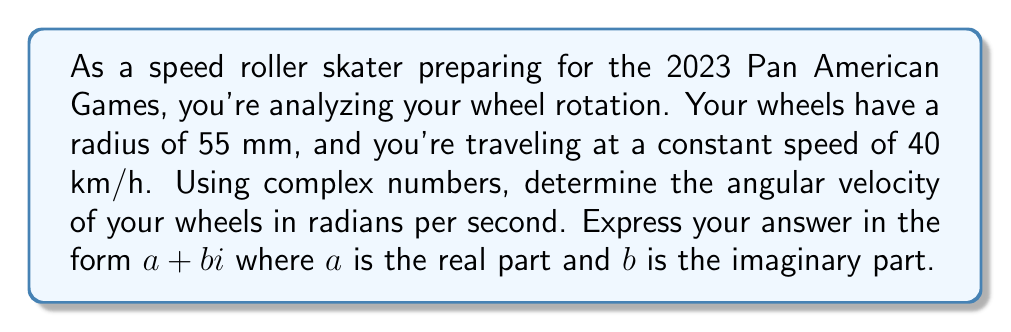Show me your answer to this math problem. Let's approach this step-by-step:

1) First, we need to convert the speed from km/h to m/s:
   $40 \text{ km/h} = 40 \times \frac{1000}{3600} \text{ m/s} = \frac{100}{9} \text{ m/s}$

2) The linear velocity $v$ is related to angular velocity $\omega$ by the equation:
   $v = r\omega$, where $r$ is the radius of the wheel.

3) Rearranging this equation, we get:
   $\omega = \frac{v}{r}$

4) Substituting our values:
   $\omega = \frac{100/9}{0.055} = \frac{2000}{99} \text{ rad/s} \approx 20.20 \text{ rad/s}$

5) Now, to express this in complex form, we need to consider that angular velocity is a vector quantity perpendicular to the plane of rotation. In the complex plane, we can represent this as a purely imaginary number:

   $\omega = 0 + \frac{2000}{99}i \text{ rad/s}$

This complex representation indicates that the rotation is occurring in the imaginary plane, which is perpendicular to the real axis (the direction of travel).
Answer: $\omega = 0 + \frac{2000}{99}i \text{ rad/s}$ 